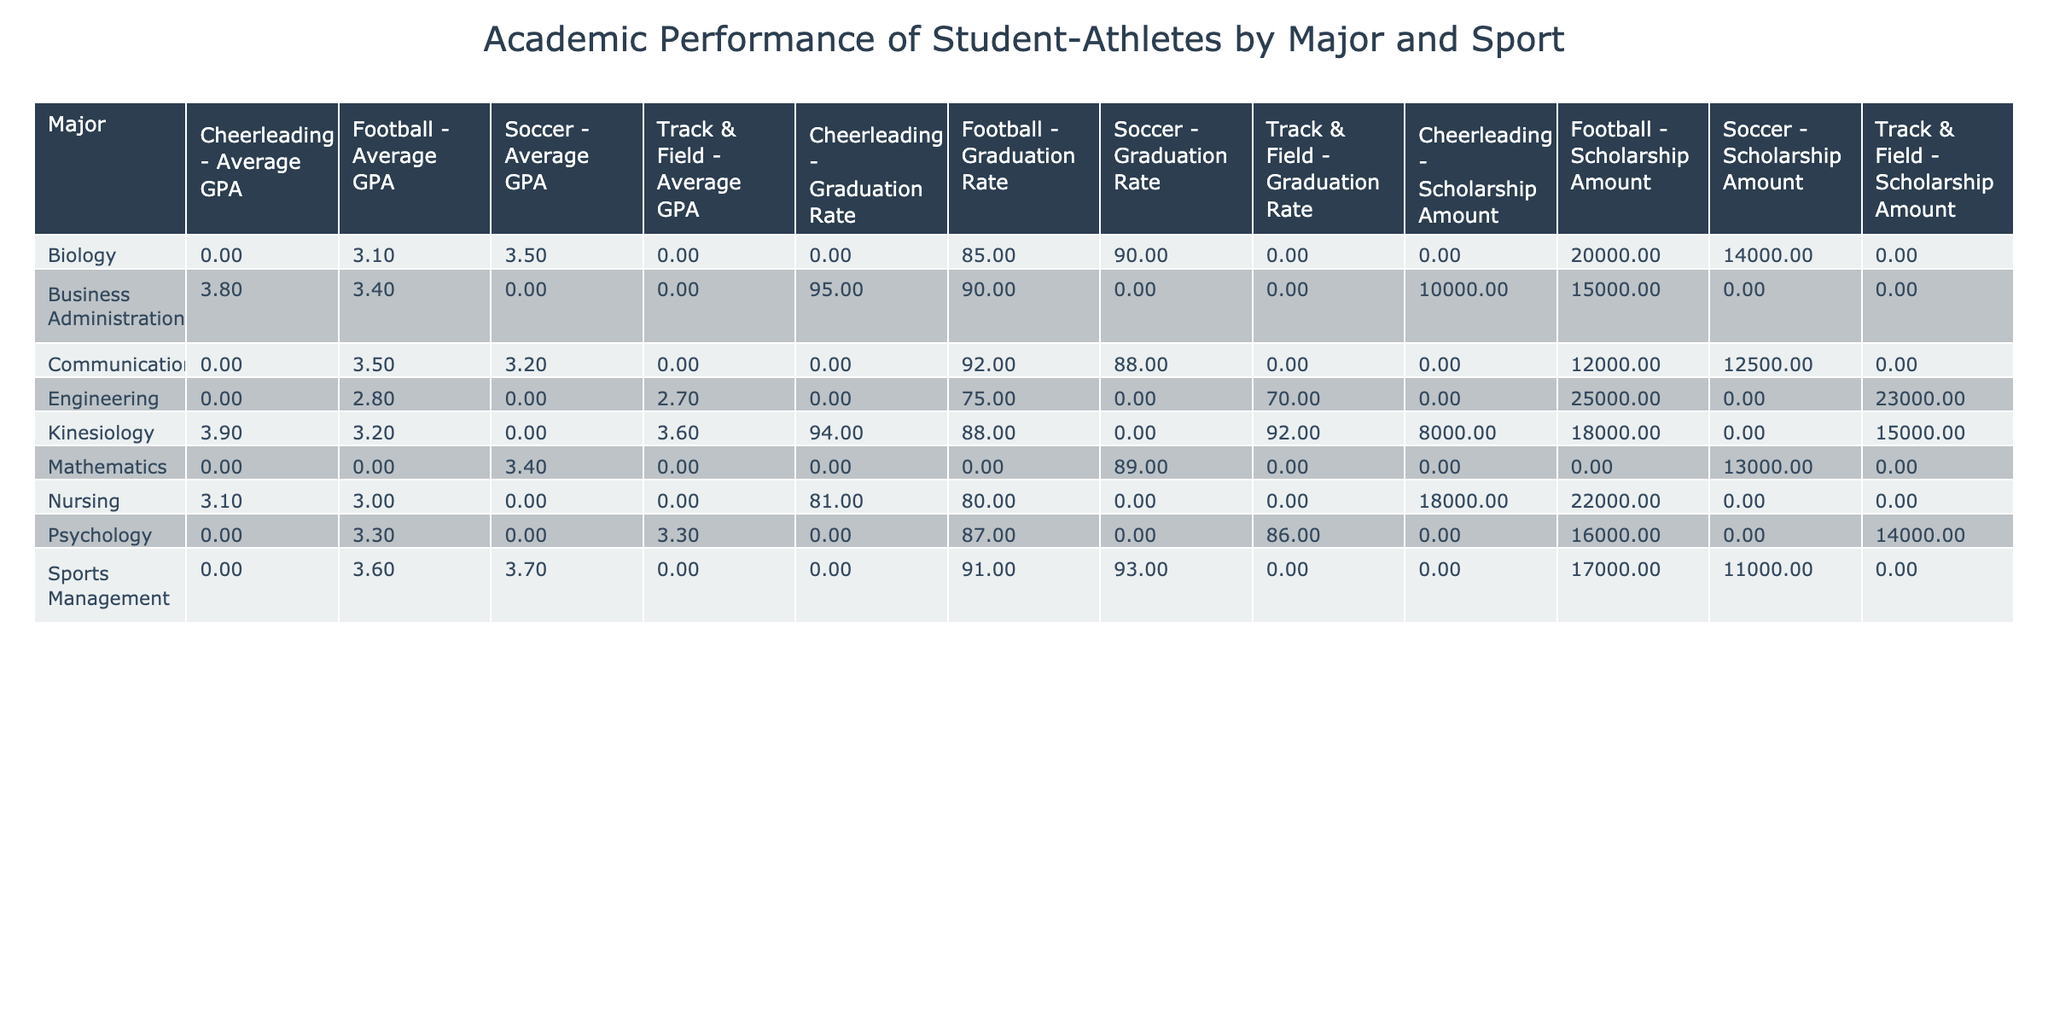What is the average GPA of student-athletes majoring in Psychology? The table shows that the average GPA for Psychology majors in Football is 3.3, and in Track & Field, it is 3.3 as well. To find the average, we take the mean of these values: (3.3 + 3.3) / 2 = 3.3. Since both values are the same, the average is 3.3.
Answer: 3.3 Which sport has the highest graduation rate for student-athletes majoring in Nursing? The table lists the graduation rate for Nursing majors in Football as 80% and in Cheerleading as 81%. Comparing these two values, 81% is higher than 80%, so Cheerleading has the highest graduation rate for Nursing majors.
Answer: Cheerleading How much scholarship money do student-athletes majoring in Engineering receive, on average? The table shows that Engineering majors receive 25,000 in Football and 23,000 in Track & Field. To calculate the average scholarship amount, we sum these values: 25,000 + 23,000 = 48,000. We then divide this sum by the number of sports (2): 48,000 / 2 = 24,000.
Answer: 24,000 Is the average GPA for Football players higher than that for Cheerleading? The average GPA for Football players by major is as follows: Biology 3.1, Business Administration 3.4, Kinesiology 3.2, Communications 3.5, Psychology 3.3, Sports Management 3.6, Nursing 3.0, Engineering 2.8. The average for these majors is (3.1 + 3.4 + 3.2 + 3.5 + 3.3 + 3.6 + 3.0 + 2.8) / 8 = 3.24. For Cheerleading, the average GPA is (3.8 + 3.9 + 3.1) / 3 = 3.6. Comparing these averages, 3.24 < 3.6, so it is false that the average GPA for Football players is higher than that for Cheerleading.
Answer: No How does the average scholarship amount for Soccer compare to that of Football? Soccer scholarship amounts are 13,000 for Mathematics, 14,000 for Biology, and 11,000 for Sports Management. Calculating the average: (13,000 + 14,000 + 11,000) / 3 = 12,666.67. For Football, the average scholarship amount is (20,000 + 15,000 + 18,000 + 12,000 + 16,000 + 17,000 + 22,000 + 25,000) / 8 = 19,500. Comparing averages, 12,666.67 < 19,500 shows that Football players receive more scholarship money on average.
Answer: Football has higher scholarship amounts 